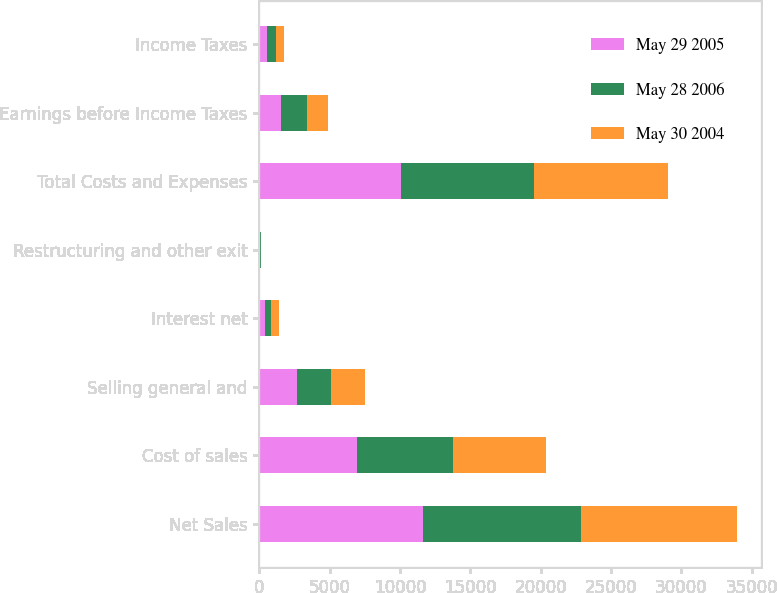Convert chart to OTSL. <chart><loc_0><loc_0><loc_500><loc_500><stacked_bar_chart><ecel><fcel>Net Sales<fcel>Cost of sales<fcel>Selling general and<fcel>Interest net<fcel>Restructuring and other exit<fcel>Total Costs and Expenses<fcel>Earnings before Income Taxes<fcel>Income Taxes<nl><fcel>May 29 2005<fcel>11640<fcel>6966<fcel>2678<fcel>399<fcel>30<fcel>10073<fcel>1567<fcel>541<nl><fcel>May 28 2006<fcel>11244<fcel>6834<fcel>2418<fcel>455<fcel>84<fcel>9429<fcel>1815<fcel>664<nl><fcel>May 30 2004<fcel>11070<fcel>6584<fcel>2443<fcel>508<fcel>26<fcel>9561<fcel>1509<fcel>528<nl></chart> 